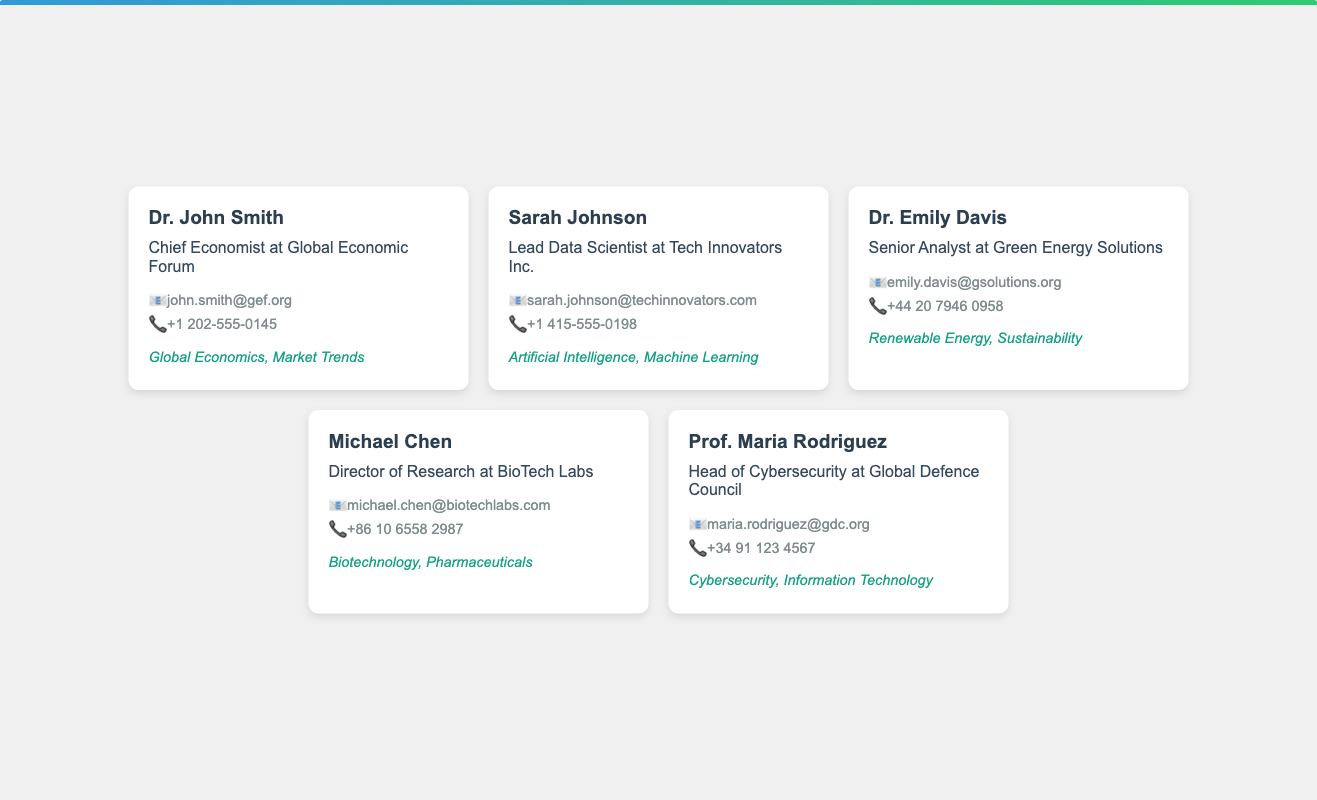What is Dr. John Smith's title? Dr. John Smith's title is listed as Chief Economist at Global Economic Forum.
Answer: Chief Economist at Global Economic Forum What is the email address of Sarah Johnson? Sarah Johnson's email address is explicitly displayed in the document.
Answer: sarah.johnson@techinnovators.com Which industry does Dr. Emily Davis specialize in? The document specifies Dr. Emily Davis's areas of expertise, which include Renewable Energy, and Sustainability.
Answer: Renewable Energy What is the phone number of Michael Chen? Michael Chen's phone number is included in the contact information on his business card.
Answer: +86 10 6558 2987 Who is the Head of Cybersecurity at Global Defence Council? The document names the individual holding this title, which requires referencing the specified business card.
Answer: Prof. Maria Rodriguez What expertise is listed for Sarah Johnson? The document details Sarah Johnson's professional specialization, which can be determined from her card.
Answer: Artificial Intelligence, Machine Learning How many people are listed in the document? By counting the individual business cards in the document, the total number of listed experts can be derived.
Answer: 5 What is the common formatting style of the phone numbers? The formatting of the phone numbers follows a uniform pattern, identifiable across all business cards in the document.
Answer: International format What is the color scheme used in the card titles? The titles on the cards employ a specific color that is consistent throughout the document.
Answer: #2c3e50 